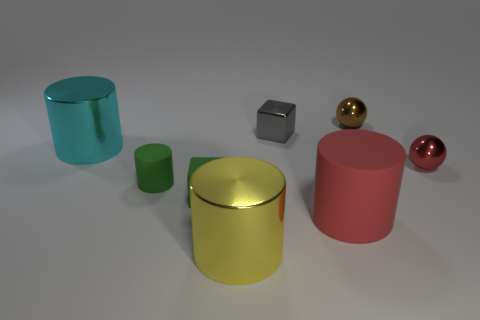Subtract all big cylinders. How many cylinders are left? 1 Subtract 1 cylinders. How many cylinders are left? 3 Subtract all red cylinders. How many cylinders are left? 3 Subtract all brown cylinders. Subtract all green cubes. How many cylinders are left? 4 Add 2 small red shiny balls. How many objects exist? 10 Subtract all blocks. How many objects are left? 6 Subtract 0 cyan spheres. How many objects are left? 8 Subtract all gray metal cubes. Subtract all gray things. How many objects are left? 6 Add 1 large yellow cylinders. How many large yellow cylinders are left? 2 Add 6 tiny green cylinders. How many tiny green cylinders exist? 7 